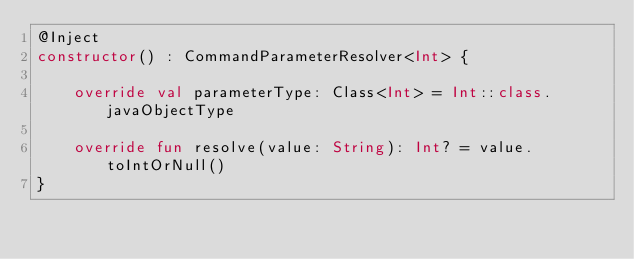Convert code to text. <code><loc_0><loc_0><loc_500><loc_500><_Kotlin_>@Inject
constructor() : CommandParameterResolver<Int> {

    override val parameterType: Class<Int> = Int::class.javaObjectType

    override fun resolve(value: String): Int? = value.toIntOrNull()
}</code> 